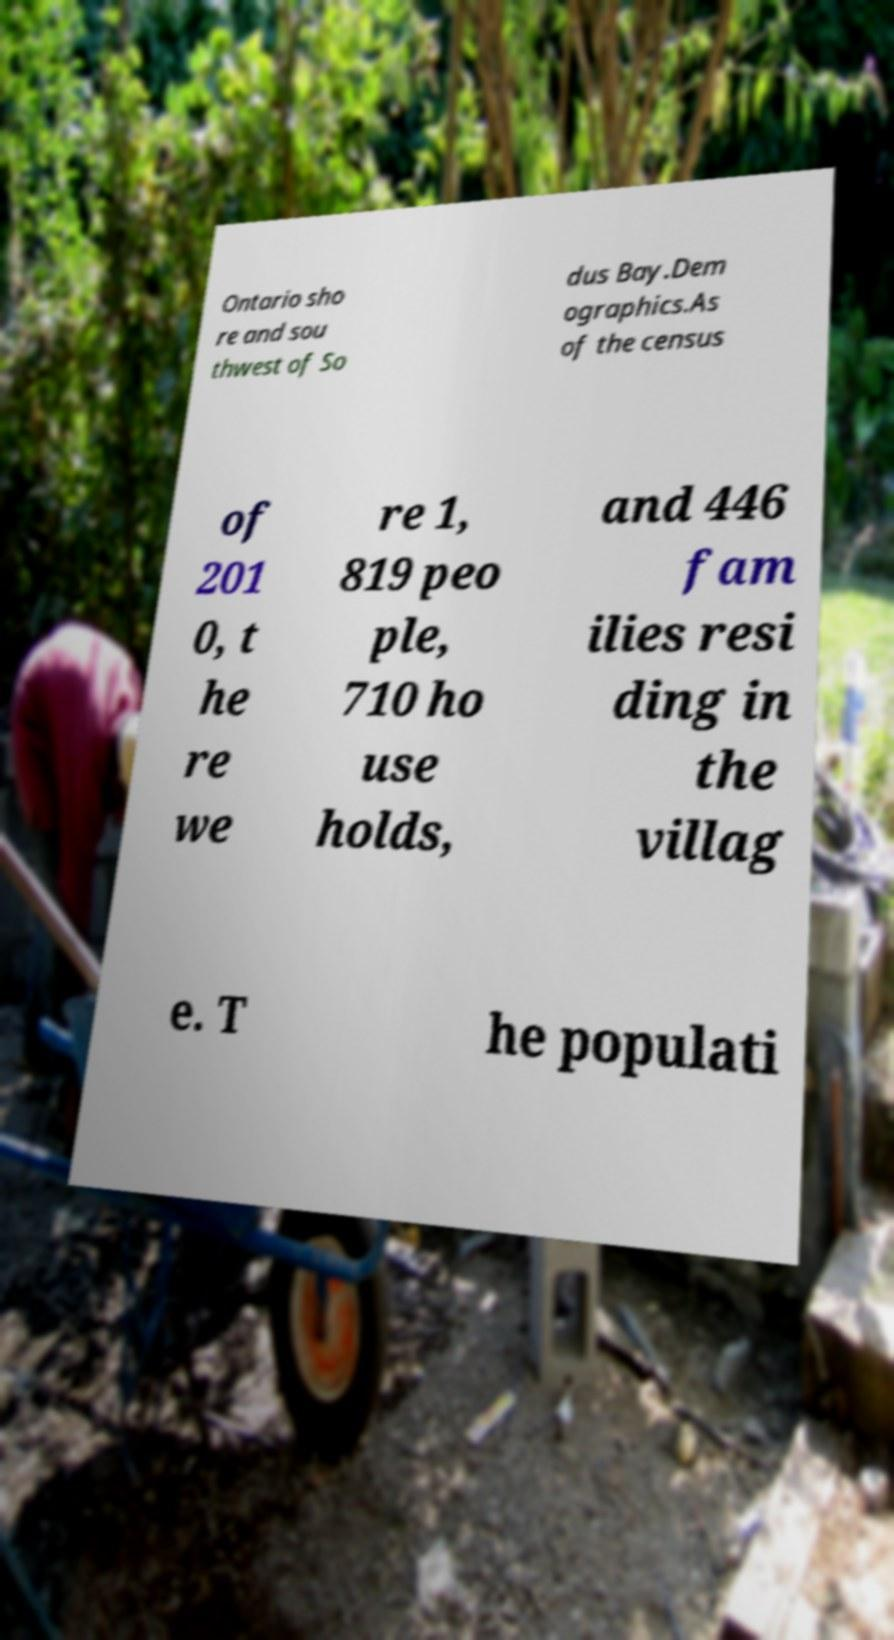Could you assist in decoding the text presented in this image and type it out clearly? Ontario sho re and sou thwest of So dus Bay.Dem ographics.As of the census of 201 0, t he re we re 1, 819 peo ple, 710 ho use holds, and 446 fam ilies resi ding in the villag e. T he populati 